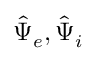Convert formula to latex. <formula><loc_0><loc_0><loc_500><loc_500>\hat { \Psi } _ { e } , \hat { \Psi } _ { i }</formula> 